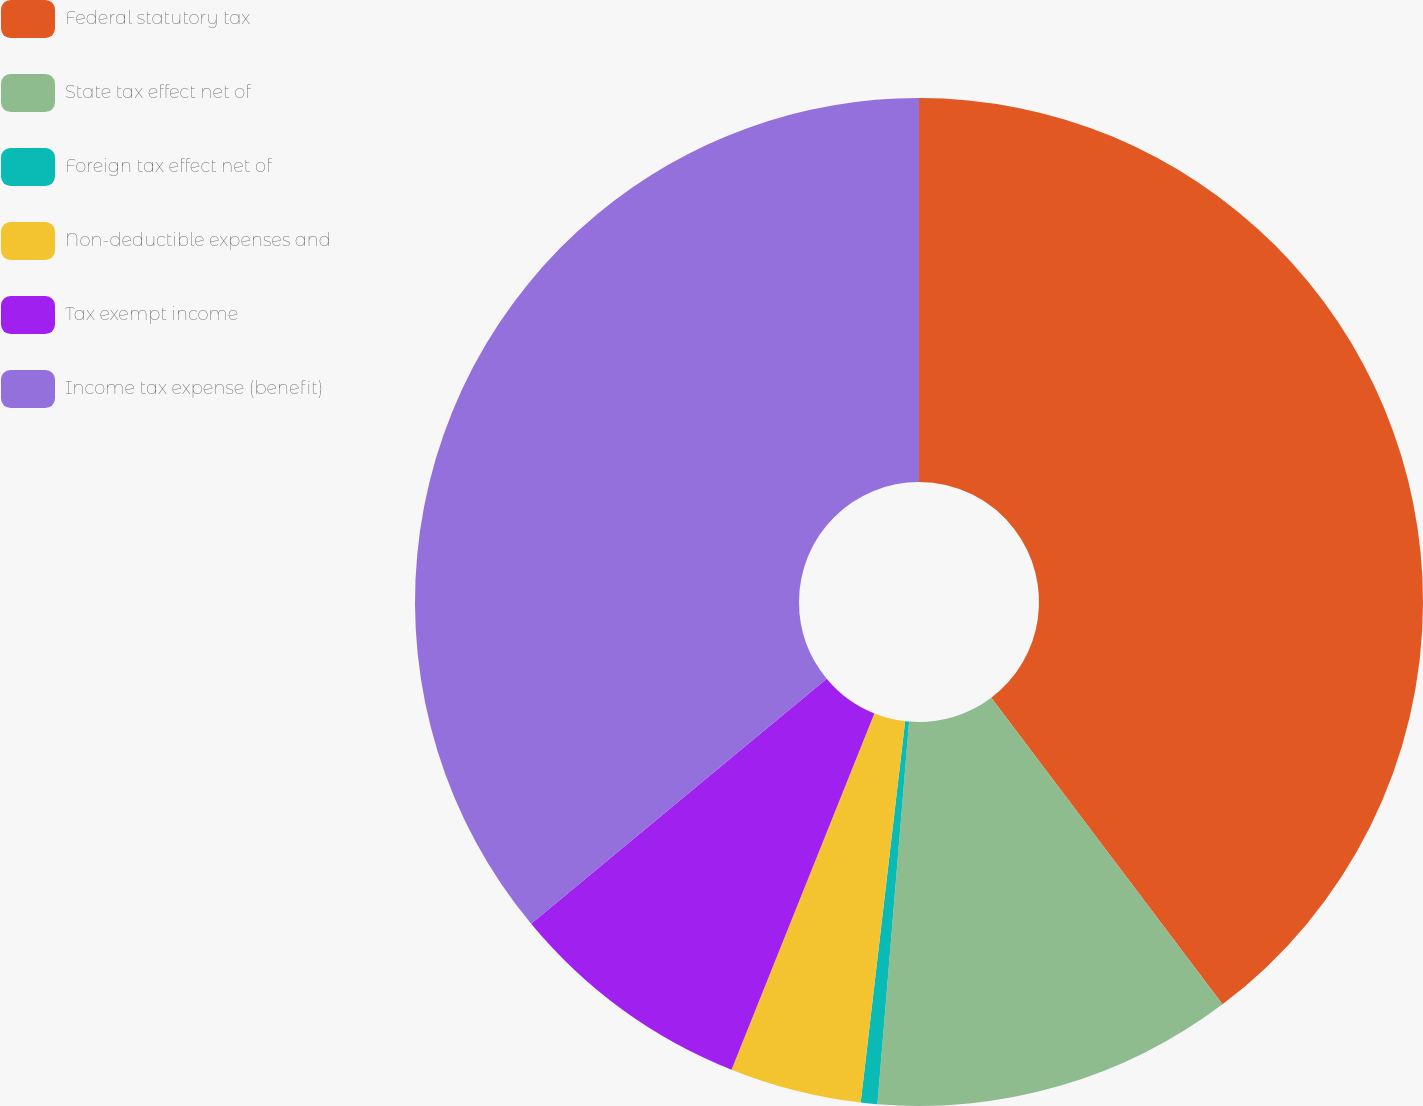Convert chart to OTSL. <chart><loc_0><loc_0><loc_500><loc_500><pie_chart><fcel>Federal statutory tax<fcel>State tax effect net of<fcel>Foreign tax effect net of<fcel>Non-deductible expenses and<fcel>Tax exempt income<fcel>Income tax expense (benefit)<nl><fcel>39.71%<fcel>11.6%<fcel>0.53%<fcel>4.22%<fcel>7.91%<fcel>36.02%<nl></chart> 